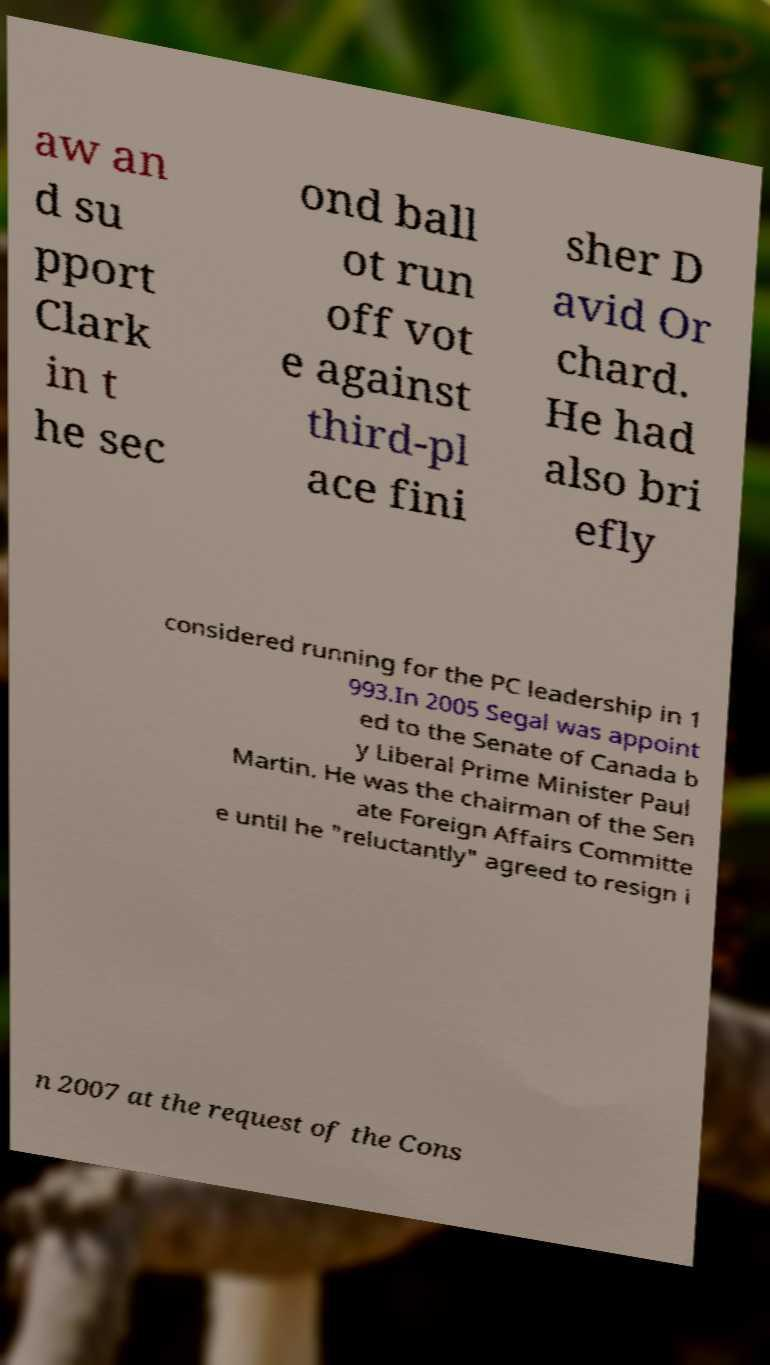I need the written content from this picture converted into text. Can you do that? aw an d su pport Clark in t he sec ond ball ot run off vot e against third-pl ace fini sher D avid Or chard. He had also bri efly considered running for the PC leadership in 1 993.In 2005 Segal was appoint ed to the Senate of Canada b y Liberal Prime Minister Paul Martin. He was the chairman of the Sen ate Foreign Affairs Committe e until he "reluctantly" agreed to resign i n 2007 at the request of the Cons 